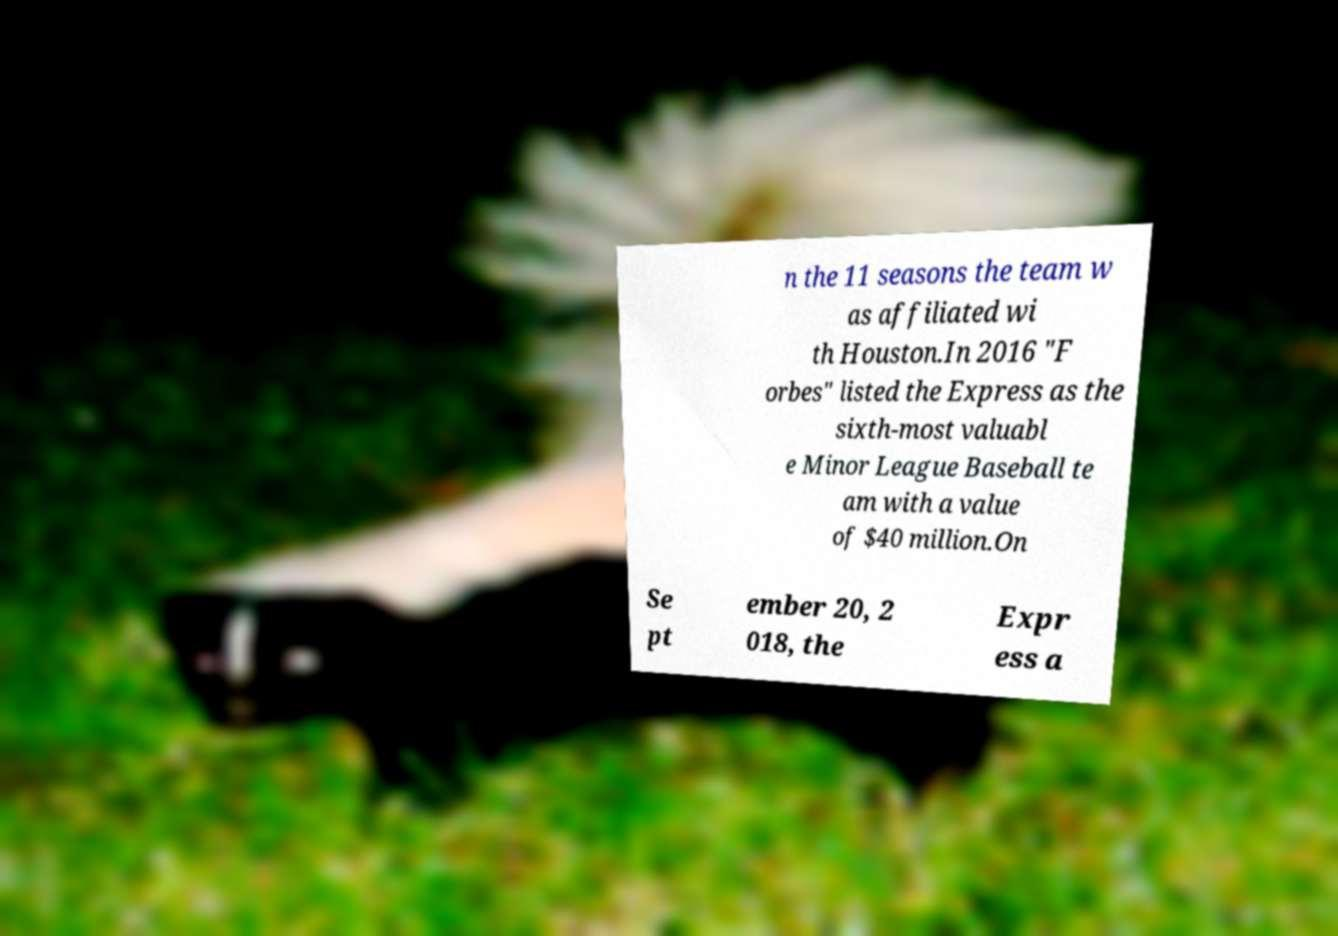Please read and relay the text visible in this image. What does it say? n the 11 seasons the team w as affiliated wi th Houston.In 2016 "F orbes" listed the Express as the sixth-most valuabl e Minor League Baseball te am with a value of $40 million.On Se pt ember 20, 2 018, the Expr ess a 